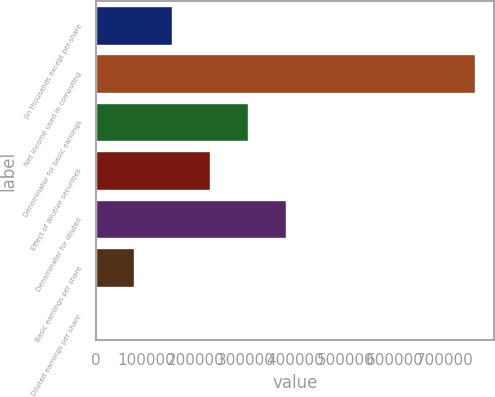<chart> <loc_0><loc_0><loc_500><loc_500><bar_chart><fcel>(in thousands except per-share<fcel>Net income used in computing<fcel>Denominator for basic earnings<fcel>Effect of dilutive securities<fcel>Denominator for diluted<fcel>Basic earnings per share<fcel>Diluted earnings per share<nl><fcel>152188<fcel>760928<fcel>304373<fcel>228280<fcel>380465<fcel>76095.1<fcel>2.5<nl></chart> 